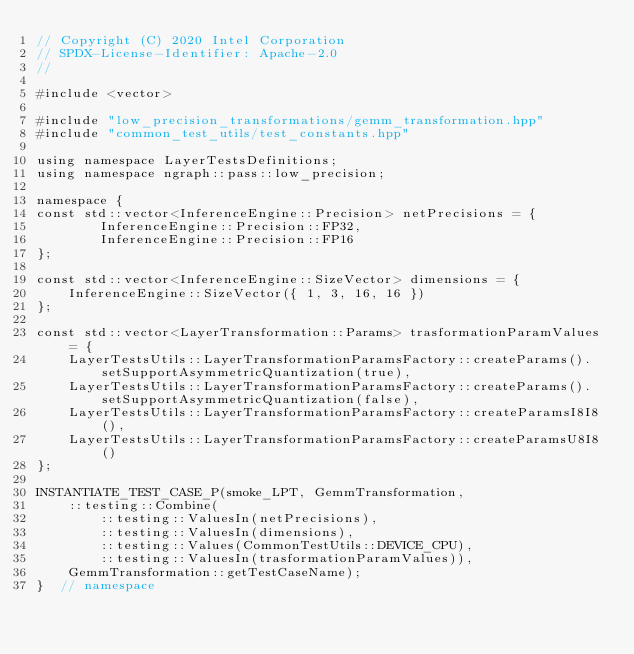<code> <loc_0><loc_0><loc_500><loc_500><_C++_>// Copyright (C) 2020 Intel Corporation
// SPDX-License-Identifier: Apache-2.0
//

#include <vector>

#include "low_precision_transformations/gemm_transformation.hpp"
#include "common_test_utils/test_constants.hpp"

using namespace LayerTestsDefinitions;
using namespace ngraph::pass::low_precision;

namespace {
const std::vector<InferenceEngine::Precision> netPrecisions = {
        InferenceEngine::Precision::FP32,
        InferenceEngine::Precision::FP16
};

const std::vector<InferenceEngine::SizeVector> dimensions = {
    InferenceEngine::SizeVector({ 1, 3, 16, 16 })
};

const std::vector<LayerTransformation::Params> trasformationParamValues = {
    LayerTestsUtils::LayerTransformationParamsFactory::createParams().setSupportAsymmetricQuantization(true),
    LayerTestsUtils::LayerTransformationParamsFactory::createParams().setSupportAsymmetricQuantization(false),
    LayerTestsUtils::LayerTransformationParamsFactory::createParamsI8I8(),
    LayerTestsUtils::LayerTransformationParamsFactory::createParamsU8I8()
};

INSTANTIATE_TEST_CASE_P(smoke_LPT, GemmTransformation,
    ::testing::Combine(
        ::testing::ValuesIn(netPrecisions),
        ::testing::ValuesIn(dimensions),
        ::testing::Values(CommonTestUtils::DEVICE_CPU),
        ::testing::ValuesIn(trasformationParamValues)),
    GemmTransformation::getTestCaseName);
}  // namespace




</code> 